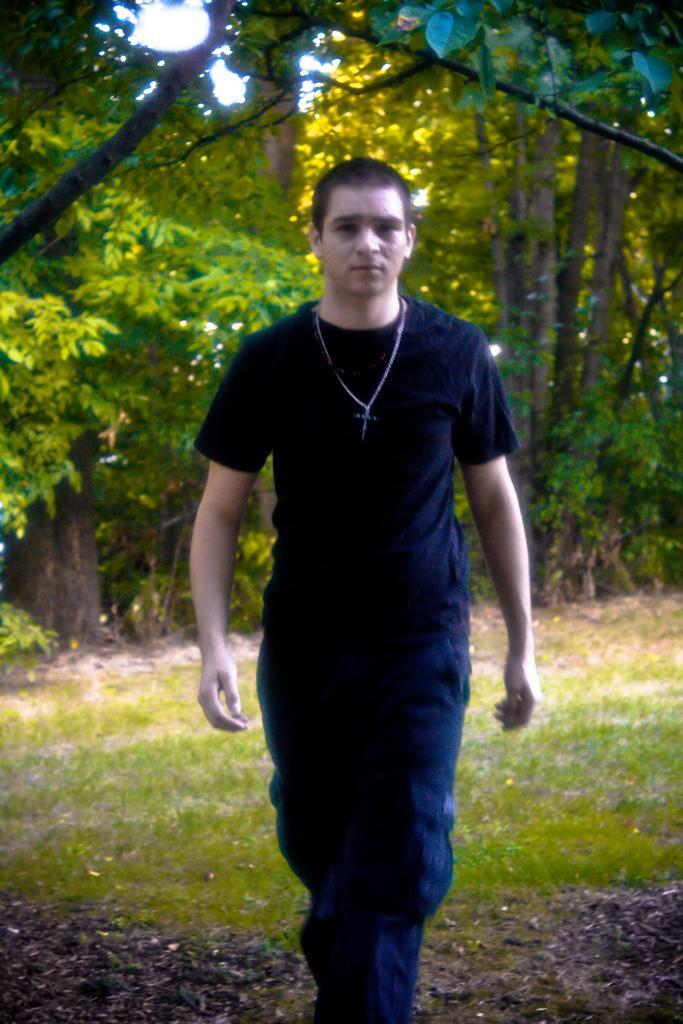In one or two sentences, can you explain what this image depicts? This is the picture of a person in black dress standing on the grass floor and behind there are some trees and plants. 